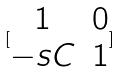Convert formula to latex. <formula><loc_0><loc_0><loc_500><loc_500>[ \begin{matrix} 1 & 0 \\ - s C & 1 \end{matrix} ]</formula> 